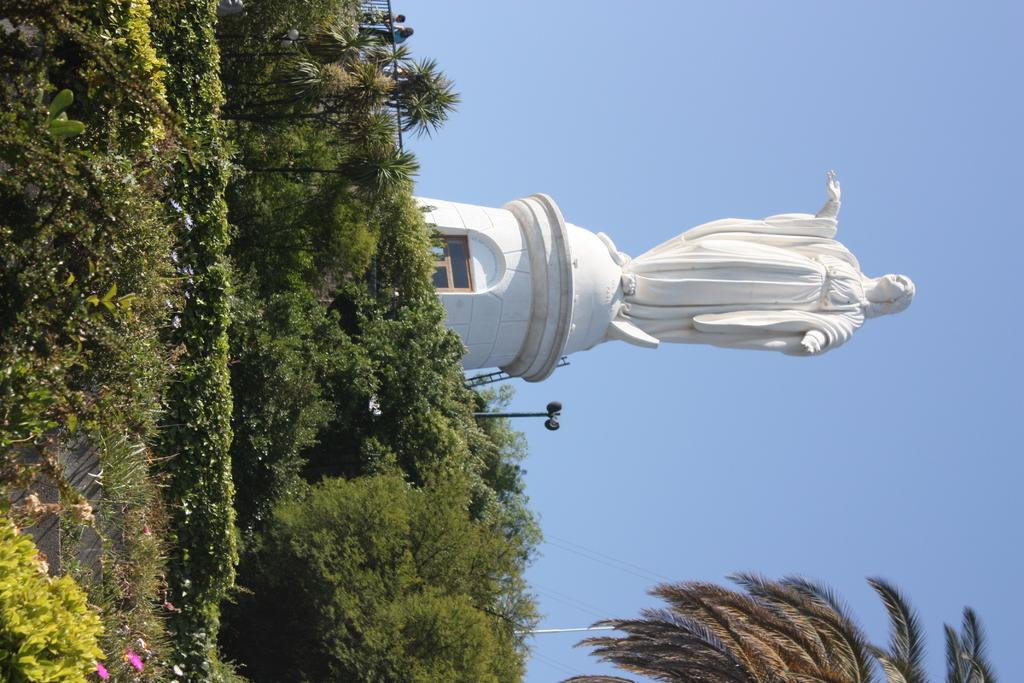What is located in the center of the image? There are plants in the center of the image. What other object can be seen in the image? There is a statue in the image. What is the color of the statue? The statue is white in color. What type of bear can be seen interacting with the statue in the image? There is no bear present in the image; it features plants and a white statue. What is the aftermath of the sponge incident in the image? There is no mention of a sponge or any incident involving a sponge in the image. 